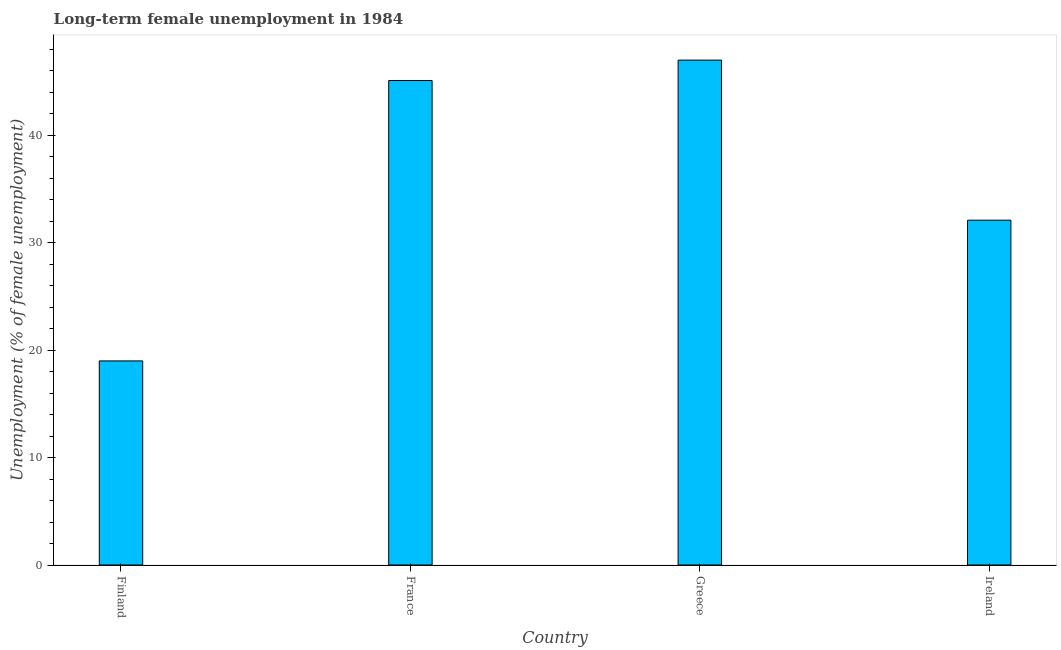What is the title of the graph?
Your response must be concise. Long-term female unemployment in 1984. What is the label or title of the Y-axis?
Your answer should be very brief. Unemployment (% of female unemployment). What is the long-term female unemployment in France?
Ensure brevity in your answer.  45.1. Across all countries, what is the minimum long-term female unemployment?
Provide a succinct answer. 19. What is the sum of the long-term female unemployment?
Your answer should be compact. 143.2. What is the average long-term female unemployment per country?
Offer a very short reply. 35.8. What is the median long-term female unemployment?
Make the answer very short. 38.6. In how many countries, is the long-term female unemployment greater than 34 %?
Your response must be concise. 2. What is the ratio of the long-term female unemployment in Finland to that in France?
Offer a terse response. 0.42. Is the difference between the long-term female unemployment in Finland and Ireland greater than the difference between any two countries?
Your response must be concise. No. What is the difference between the highest and the second highest long-term female unemployment?
Provide a short and direct response. 1.9. What is the difference between the highest and the lowest long-term female unemployment?
Your answer should be compact. 28. In how many countries, is the long-term female unemployment greater than the average long-term female unemployment taken over all countries?
Your answer should be very brief. 2. How many countries are there in the graph?
Your response must be concise. 4. Are the values on the major ticks of Y-axis written in scientific E-notation?
Offer a very short reply. No. What is the Unemployment (% of female unemployment) of France?
Your answer should be very brief. 45.1. What is the Unemployment (% of female unemployment) in Ireland?
Offer a very short reply. 32.1. What is the difference between the Unemployment (% of female unemployment) in Finland and France?
Your response must be concise. -26.1. What is the difference between the Unemployment (% of female unemployment) in France and Ireland?
Give a very brief answer. 13. What is the ratio of the Unemployment (% of female unemployment) in Finland to that in France?
Your answer should be very brief. 0.42. What is the ratio of the Unemployment (% of female unemployment) in Finland to that in Greece?
Provide a short and direct response. 0.4. What is the ratio of the Unemployment (% of female unemployment) in Finland to that in Ireland?
Ensure brevity in your answer.  0.59. What is the ratio of the Unemployment (% of female unemployment) in France to that in Ireland?
Give a very brief answer. 1.41. What is the ratio of the Unemployment (% of female unemployment) in Greece to that in Ireland?
Ensure brevity in your answer.  1.46. 